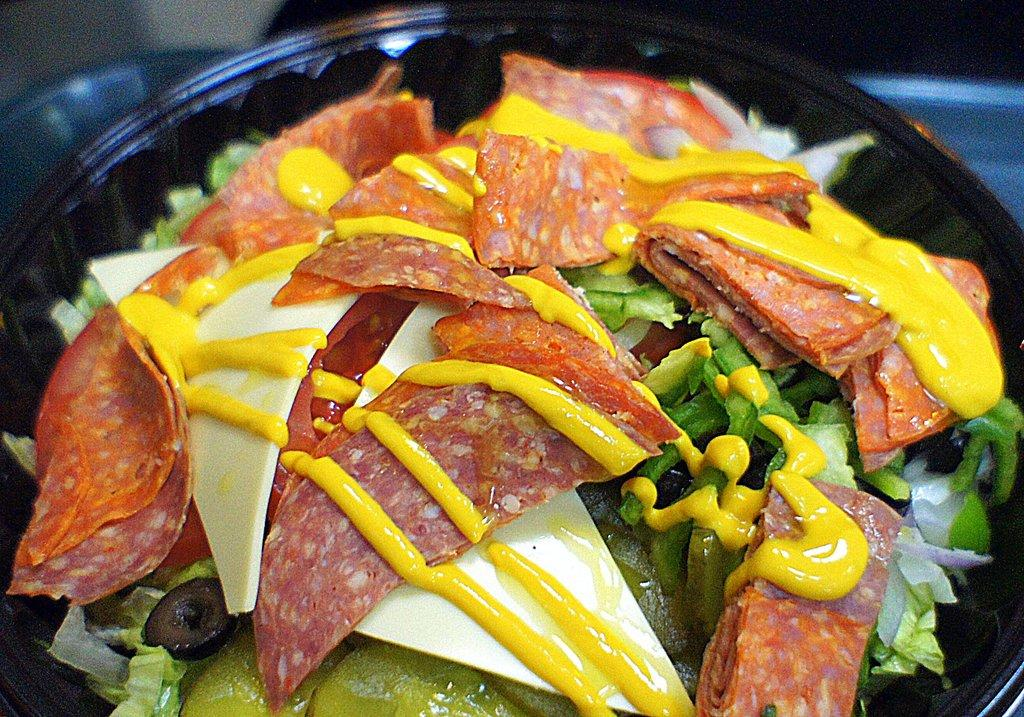What object is in the center of the image? There is a plate in the center of the image. What is on the plate? The plate contains food. What type of stone can be smelled in the image? There is no stone present in the image, and therefore no scent can be associated with it. 